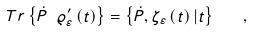<formula> <loc_0><loc_0><loc_500><loc_500>T r \left \{ \dot { P } \ \varrho _ { \varepsilon } ^ { \prime } \left ( t \right ) \right \} = \left \{ \dot { P } , \zeta _ { \varepsilon } \left ( t \right ) | t \right \} \quad ,</formula> 